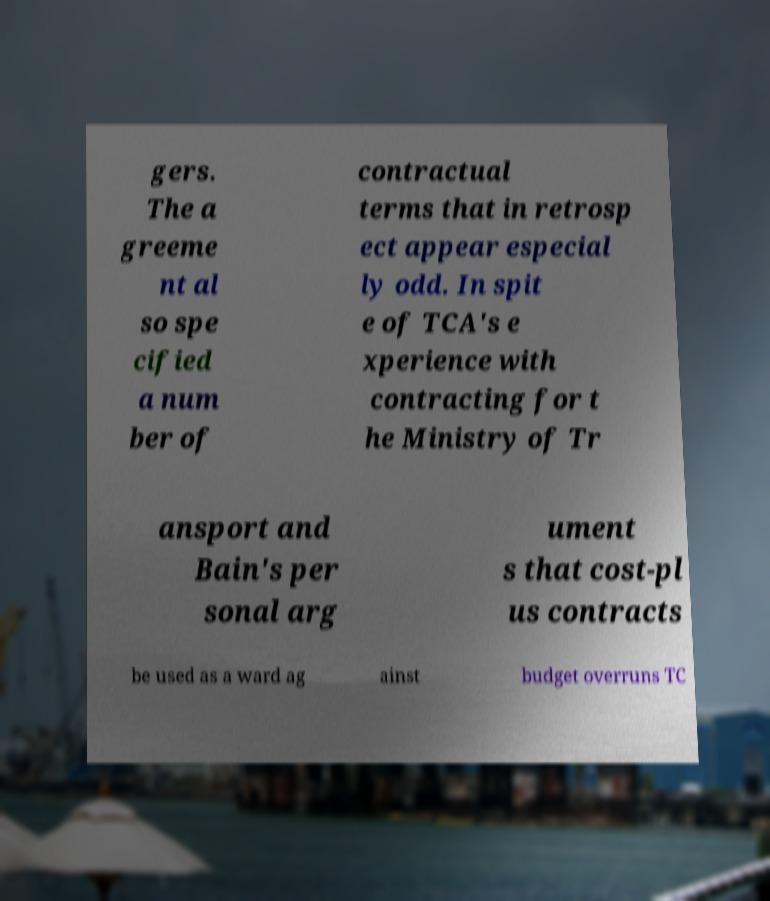Can you accurately transcribe the text from the provided image for me? gers. The a greeme nt al so spe cified a num ber of contractual terms that in retrosp ect appear especial ly odd. In spit e of TCA's e xperience with contracting for t he Ministry of Tr ansport and Bain's per sonal arg ument s that cost-pl us contracts be used as a ward ag ainst budget overruns TC 